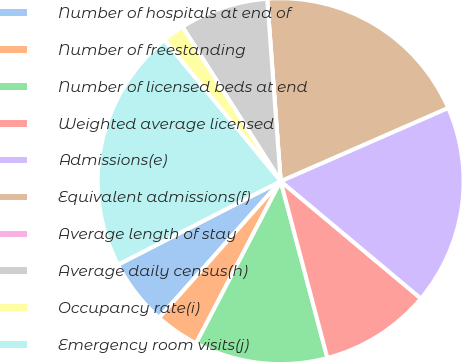Convert chart to OTSL. <chart><loc_0><loc_0><loc_500><loc_500><pie_chart><fcel>Number of hospitals at end of<fcel>Number of freestanding<fcel>Number of licensed beds at end<fcel>Weighted average licensed<fcel>Admissions(e)<fcel>Equivalent admissions(f)<fcel>Average length of stay<fcel>Average daily census(h)<fcel>Occupancy rate(i)<fcel>Emergency room visits(j)<nl><fcel>5.88%<fcel>3.92%<fcel>11.76%<fcel>9.8%<fcel>17.65%<fcel>19.61%<fcel>0.0%<fcel>7.84%<fcel>1.96%<fcel>21.57%<nl></chart> 